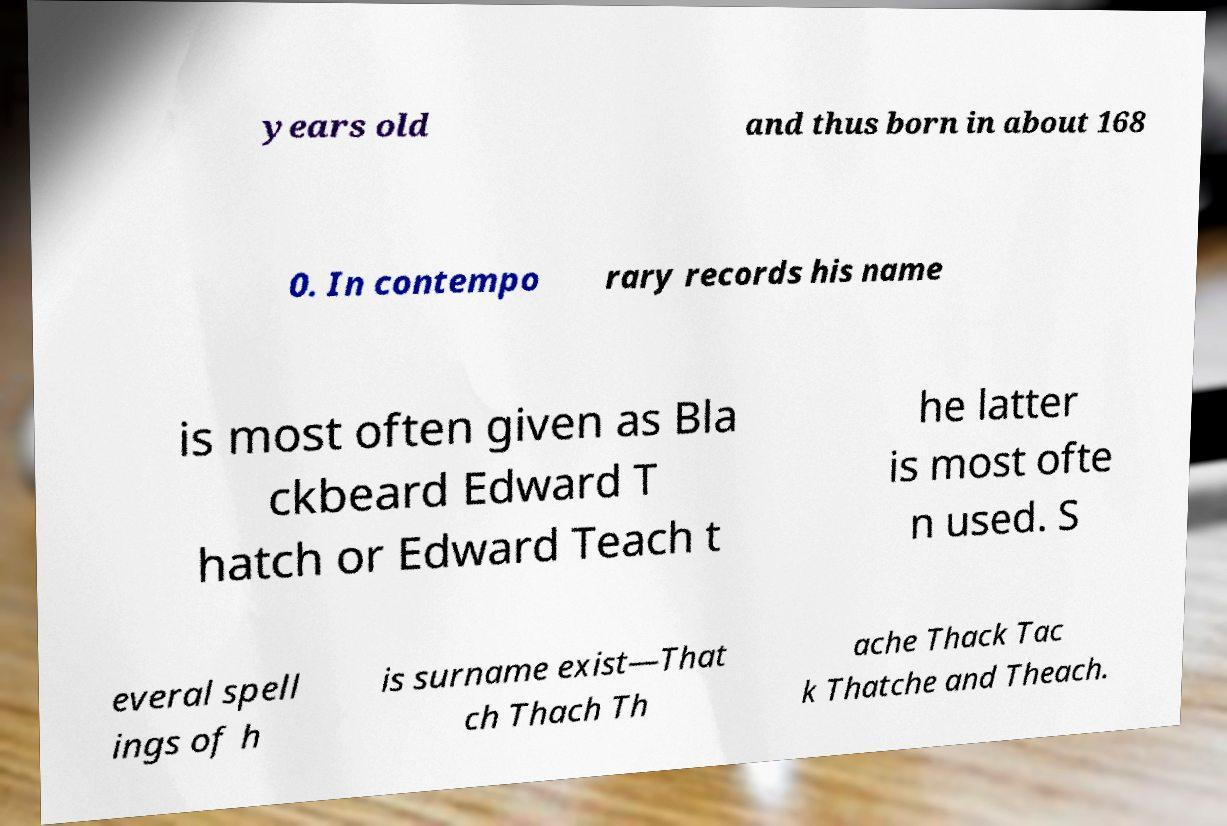There's text embedded in this image that I need extracted. Can you transcribe it verbatim? years old and thus born in about 168 0. In contempo rary records his name is most often given as Bla ckbeard Edward T hatch or Edward Teach t he latter is most ofte n used. S everal spell ings of h is surname exist—That ch Thach Th ache Thack Tac k Thatche and Theach. 